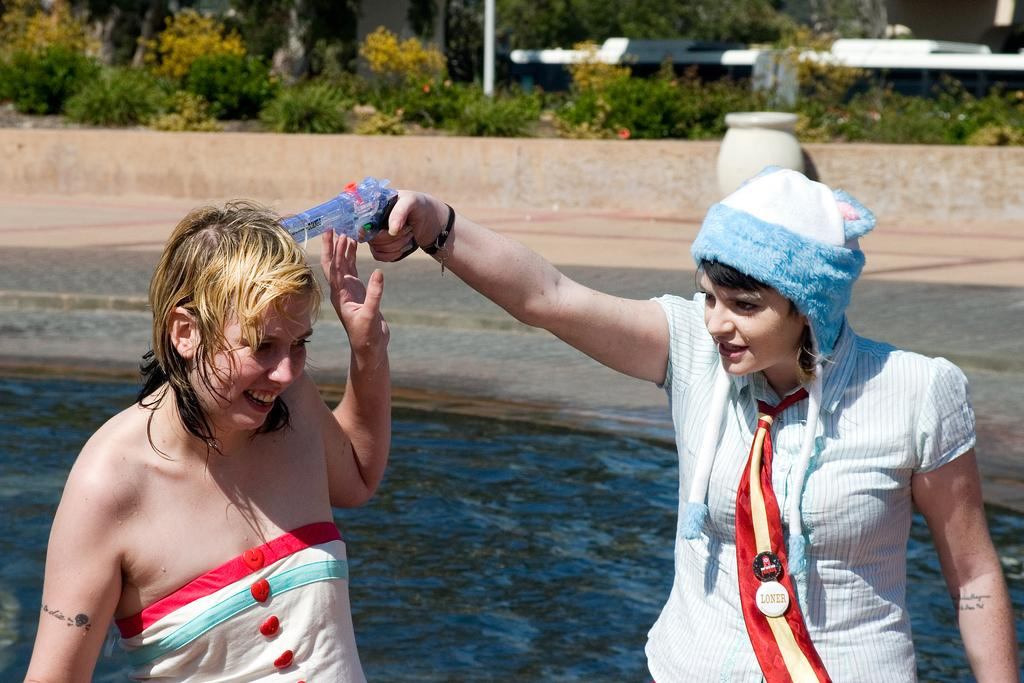How many women are in the image? There are two women in the foreground of the image. What are the women doing in the image? The women are in the water. What can be seen in the background of the image? There is a fence, a flower pot, plants, a pole, and trees in the background of the image. Can you describe the possible location of the image? The image may have been taken near a swimming pool, as the women are in the water. What sound does the whistle make in the image? There is no whistle present in the image. 